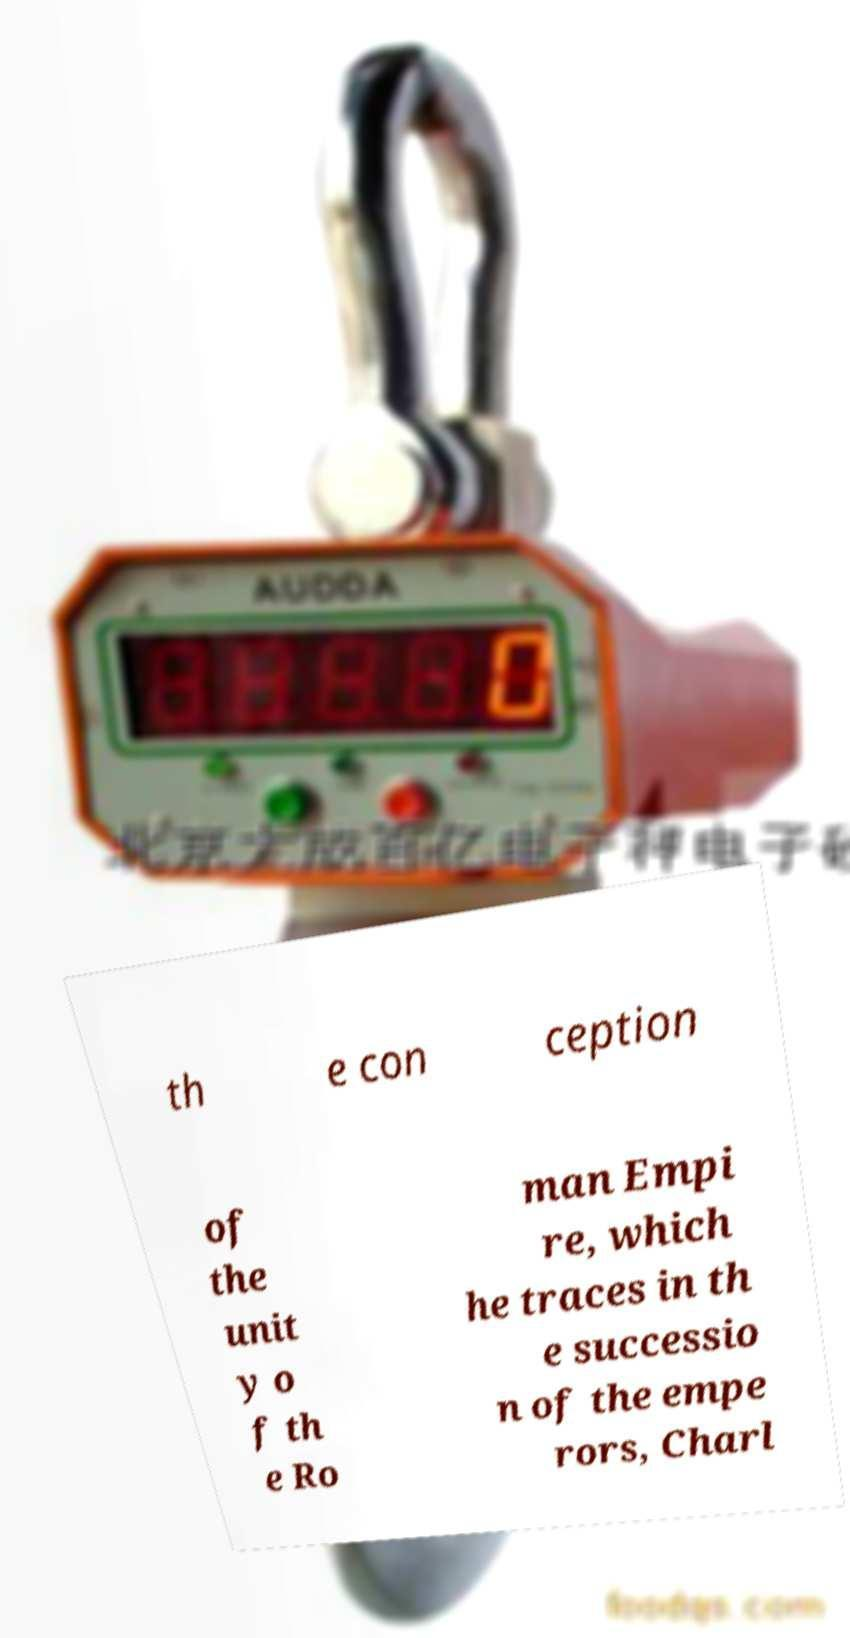There's text embedded in this image that I need extracted. Can you transcribe it verbatim? th e con ception of the unit y o f th e Ro man Empi re, which he traces in th e successio n of the empe rors, Charl 